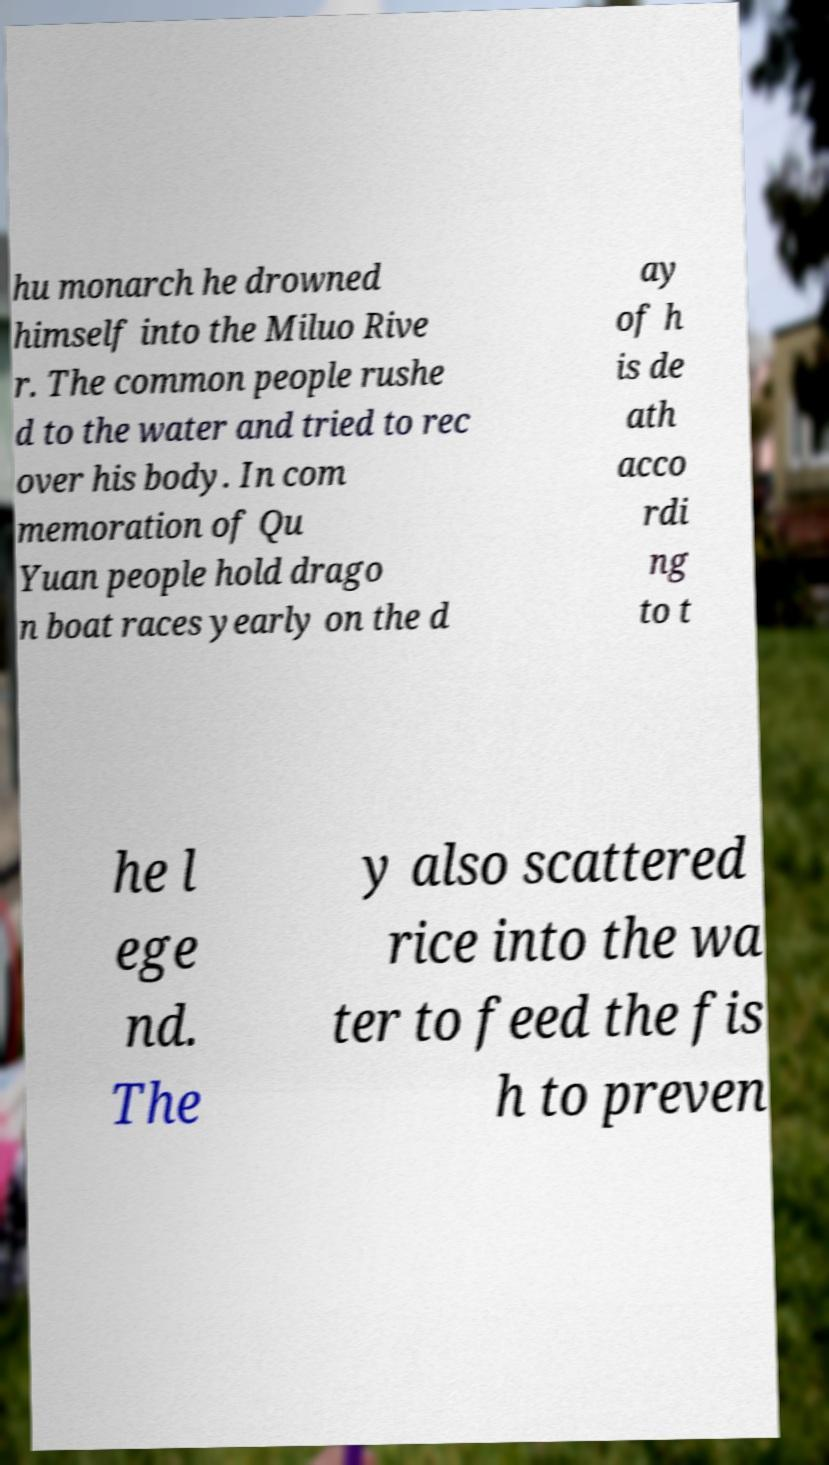Please identify and transcribe the text found in this image. hu monarch he drowned himself into the Miluo Rive r. The common people rushe d to the water and tried to rec over his body. In com memoration of Qu Yuan people hold drago n boat races yearly on the d ay of h is de ath acco rdi ng to t he l ege nd. The y also scattered rice into the wa ter to feed the fis h to preven 